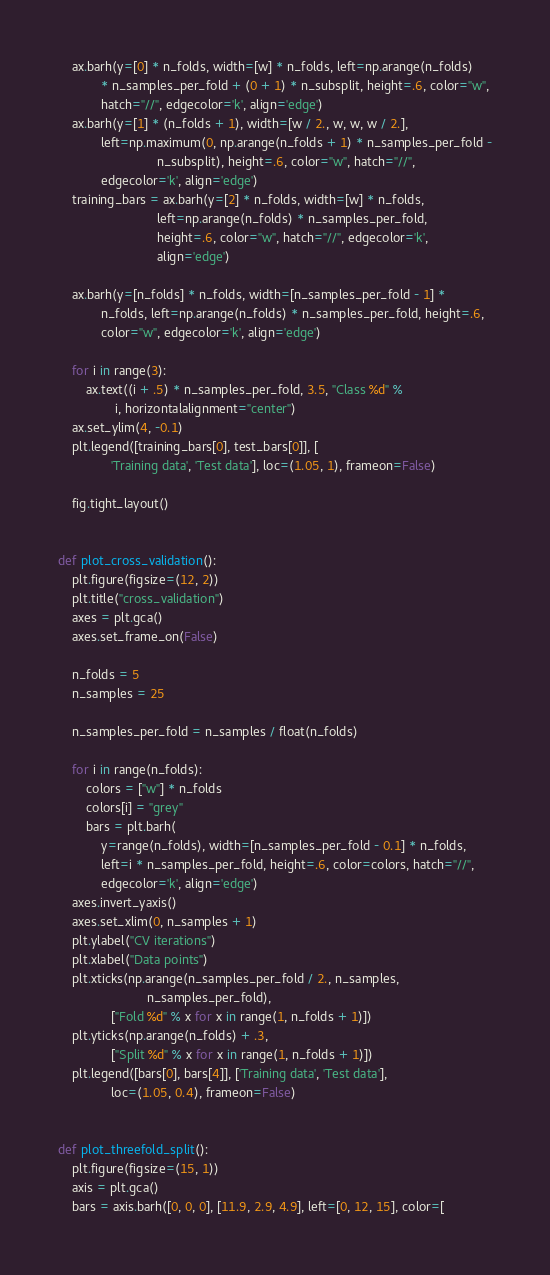<code> <loc_0><loc_0><loc_500><loc_500><_Python_>    ax.barh(y=[0] * n_folds, width=[w] * n_folds, left=np.arange(n_folds)
            * n_samples_per_fold + (0 + 1) * n_subsplit, height=.6, color="w",
            hatch="//", edgecolor='k', align='edge')
    ax.barh(y=[1] * (n_folds + 1), width=[w / 2., w, w, w / 2.],
            left=np.maximum(0, np.arange(n_folds + 1) * n_samples_per_fold -
                            n_subsplit), height=.6, color="w", hatch="//",
            edgecolor='k', align='edge')
    training_bars = ax.barh(y=[2] * n_folds, width=[w] * n_folds,
                            left=np.arange(n_folds) * n_samples_per_fold,
                            height=.6, color="w", hatch="//", edgecolor='k',
                            align='edge')

    ax.barh(y=[n_folds] * n_folds, width=[n_samples_per_fold - 1] *
            n_folds, left=np.arange(n_folds) * n_samples_per_fold, height=.6,
            color="w", edgecolor='k', align='edge')

    for i in range(3):
        ax.text((i + .5) * n_samples_per_fold, 3.5, "Class %d" %
                i, horizontalalignment="center")
    ax.set_ylim(4, -0.1)
    plt.legend([training_bars[0], test_bars[0]], [
               'Training data', 'Test data'], loc=(1.05, 1), frameon=False)

    fig.tight_layout()


def plot_cross_validation():
    plt.figure(figsize=(12, 2))
    plt.title("cross_validation")
    axes = plt.gca()
    axes.set_frame_on(False)

    n_folds = 5
    n_samples = 25

    n_samples_per_fold = n_samples / float(n_folds)

    for i in range(n_folds):
        colors = ["w"] * n_folds
        colors[i] = "grey"
        bars = plt.barh(
            y=range(n_folds), width=[n_samples_per_fold - 0.1] * n_folds,
            left=i * n_samples_per_fold, height=.6, color=colors, hatch="//",
            edgecolor='k', align='edge')
    axes.invert_yaxis()
    axes.set_xlim(0, n_samples + 1)
    plt.ylabel("CV iterations")
    plt.xlabel("Data points")
    plt.xticks(np.arange(n_samples_per_fold / 2., n_samples,
                         n_samples_per_fold),
               ["Fold %d" % x for x in range(1, n_folds + 1)])
    plt.yticks(np.arange(n_folds) + .3,
               ["Split %d" % x for x in range(1, n_folds + 1)])
    plt.legend([bars[0], bars[4]], ['Training data', 'Test data'],
               loc=(1.05, 0.4), frameon=False)


def plot_threefold_split():
    plt.figure(figsize=(15, 1))
    axis = plt.gca()
    bars = axis.barh([0, 0, 0], [11.9, 2.9, 4.9], left=[0, 12, 15], color=[</code> 